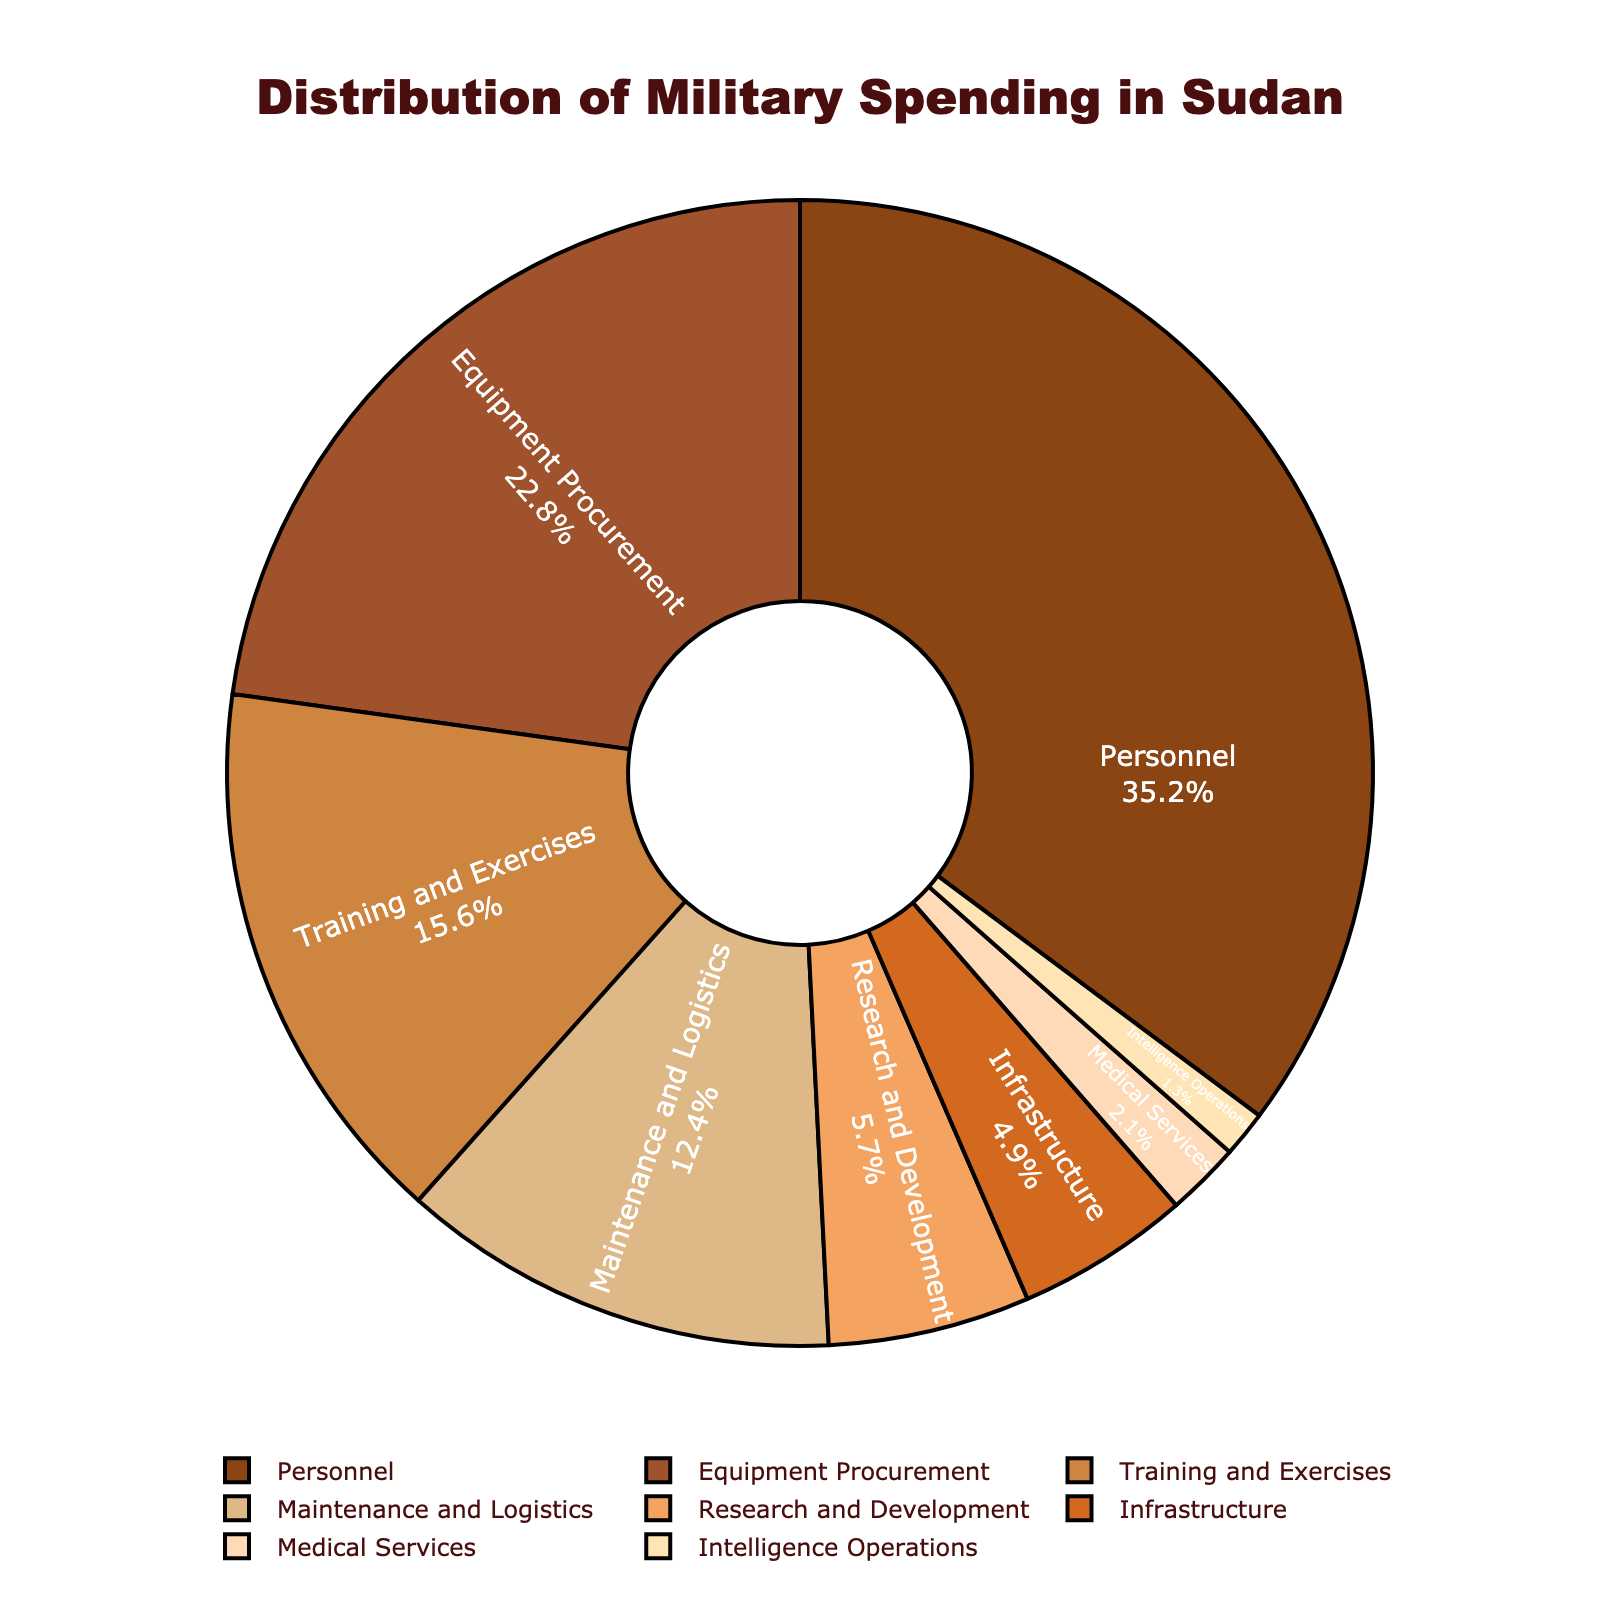What sector receives the highest percentage of military spending? The figure shows various sectors with their associated percentages of military spending. The sector with the highest percentage is "Personnel" with 35.2%.
Answer: Personnel What two sectors combined account for nearly 50% of the military spending? By examining the percentages, "Personnel" has 35.2% and "Equipment Procurement" has 22.8%. When added together, their sum is 58%, which is close to 50%.
Answer: Personnel and Equipment Procurement Which sector receives the least amount of military spending? From the figure, the sector with the smallest percentage is "Intelligence Operations" at 1.3%.
Answer: Intelligence Operations How much more is spent on Personnel compared to Maintenance and Logistics? Personnel spending is 35.2%, and Maintenance and Logistics is 12.4%. The difference is 35.2% - 12.4% = 22.8%.
Answer: 22.8% Is the spending on Infrastructure greater than the spending on Medical Services? The Infrastructure spending is 4.9%, and Medical Services spending is 2.1%. Since 4.9% > 2.1%, Infrastructure receives more funding.
Answer: Yes What is the total percentage of military spending on Training and Exercises, Maintenance and Logistics, and Infrastructure? The percentages for Training and Exercises, Maintenance and Logistics, and Infrastructure are 15.6%, 12.4%, and 4.9%, respectively. Adding these gives 15.6% + 12.4% + 4.9% = 32.9%.
Answer: 32.9% Which sector among Research and Development and Equipment Procurement has a higher percentage, and by how much? Research and Development has 5.7%, and Equipment Procurement has 22.8%. The difference is 22.8% - 5.7% = 17.1%. Equipment Procurement has a higher percentage by 17.1%.
Answer: Equipment Procurement by 17.1% What percentage of spending is allocated to Intelligence Operations and Medical Services combined? Intelligence Operations receives 1.3%, and Medical Services receives 2.1%. Adding these gives 1.3% + 2.1% = 3.4%.
Answer: 3.4% By how much does the spending on Training and Exercises exceed that of Medical Services? Training and Exercises spend 15.6%, and Medical Services spend 2.1%. The difference is 15.6% - 2.1% = 13.5%.
Answer: 13.5% Which color represents the sector with the highest spending, and what is it? The color representing the sector with the highest spending ("Personnel" with 35.2%) is brown.
Answer: Brown 